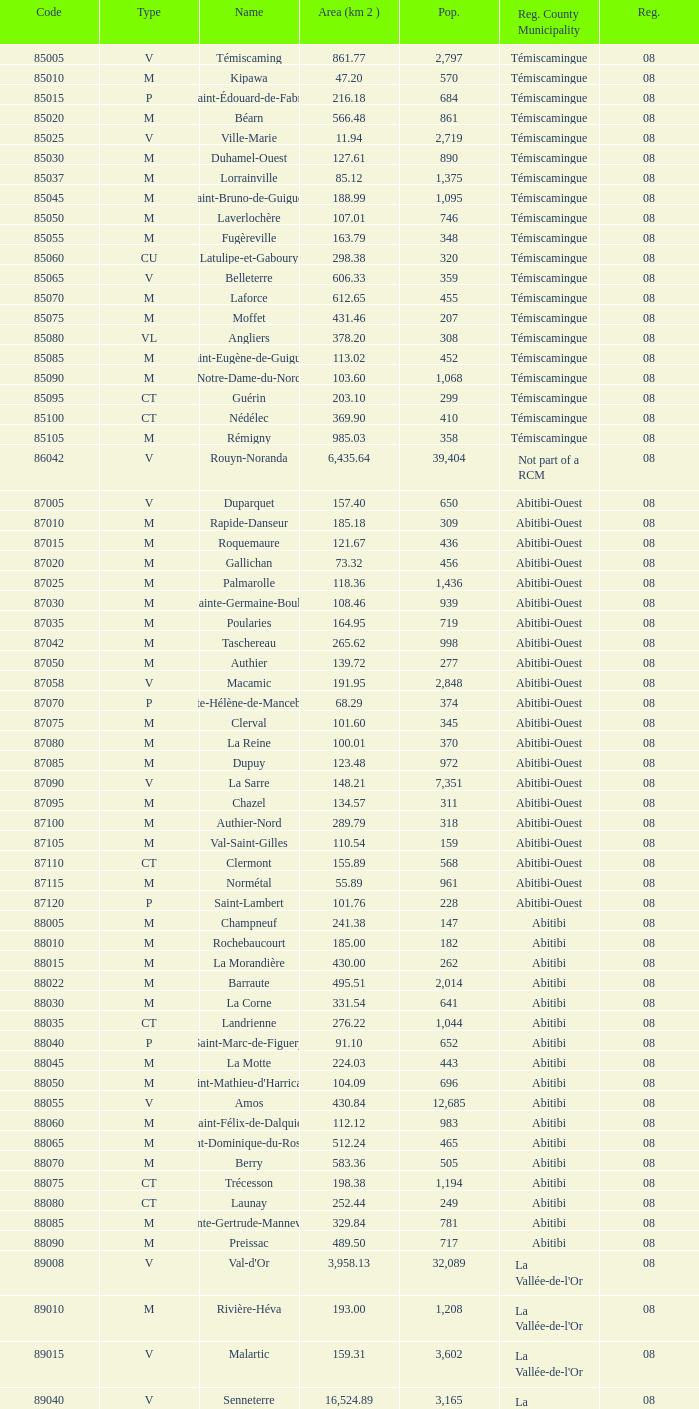What municipality has 719 people and is larger than 108.46 km2? Abitibi-Ouest. Could you help me parse every detail presented in this table? {'header': ['Code', 'Type', 'Name', 'Area (km 2 )', 'Pop.', 'Reg. County Municipality', 'Reg.'], 'rows': [['85005', 'V', 'Témiscaming', '861.77', '2,797', 'Témiscamingue', '08'], ['85010', 'M', 'Kipawa', '47.20', '570', 'Témiscamingue', '08'], ['85015', 'P', 'Saint-Édouard-de-Fabre', '216.18', '684', 'Témiscamingue', '08'], ['85020', 'M', 'Béarn', '566.48', '861', 'Témiscamingue', '08'], ['85025', 'V', 'Ville-Marie', '11.94', '2,719', 'Témiscamingue', '08'], ['85030', 'M', 'Duhamel-Ouest', '127.61', '890', 'Témiscamingue', '08'], ['85037', 'M', 'Lorrainville', '85.12', '1,375', 'Témiscamingue', '08'], ['85045', 'M', 'Saint-Bruno-de-Guigues', '188.99', '1,095', 'Témiscamingue', '08'], ['85050', 'M', 'Laverlochère', '107.01', '746', 'Témiscamingue', '08'], ['85055', 'M', 'Fugèreville', '163.79', '348', 'Témiscamingue', '08'], ['85060', 'CU', 'Latulipe-et-Gaboury', '298.38', '320', 'Témiscamingue', '08'], ['85065', 'V', 'Belleterre', '606.33', '359', 'Témiscamingue', '08'], ['85070', 'M', 'Laforce', '612.65', '455', 'Témiscamingue', '08'], ['85075', 'M', 'Moffet', '431.46', '207', 'Témiscamingue', '08'], ['85080', 'VL', 'Angliers', '378.20', '308', 'Témiscamingue', '08'], ['85085', 'M', 'Saint-Eugène-de-Guigues', '113.02', '452', 'Témiscamingue', '08'], ['85090', 'M', 'Notre-Dame-du-Nord', '103.60', '1,068', 'Témiscamingue', '08'], ['85095', 'CT', 'Guérin', '203.10', '299', 'Témiscamingue', '08'], ['85100', 'CT', 'Nédélec', '369.90', '410', 'Témiscamingue', '08'], ['85105', 'M', 'Rémigny', '985.03', '358', 'Témiscamingue', '08'], ['86042', 'V', 'Rouyn-Noranda', '6,435.64', '39,404', 'Not part of a RCM', '08'], ['87005', 'V', 'Duparquet', '157.40', '650', 'Abitibi-Ouest', '08'], ['87010', 'M', 'Rapide-Danseur', '185.18', '309', 'Abitibi-Ouest', '08'], ['87015', 'M', 'Roquemaure', '121.67', '436', 'Abitibi-Ouest', '08'], ['87020', 'M', 'Gallichan', '73.32', '456', 'Abitibi-Ouest', '08'], ['87025', 'M', 'Palmarolle', '118.36', '1,436', 'Abitibi-Ouest', '08'], ['87030', 'M', 'Sainte-Germaine-Boulé', '108.46', '939', 'Abitibi-Ouest', '08'], ['87035', 'M', 'Poularies', '164.95', '719', 'Abitibi-Ouest', '08'], ['87042', 'M', 'Taschereau', '265.62', '998', 'Abitibi-Ouest', '08'], ['87050', 'M', 'Authier', '139.72', '277', 'Abitibi-Ouest', '08'], ['87058', 'V', 'Macamic', '191.95', '2,848', 'Abitibi-Ouest', '08'], ['87070', 'P', 'Sainte-Hélène-de-Mancebourg', '68.29', '374', 'Abitibi-Ouest', '08'], ['87075', 'M', 'Clerval', '101.60', '345', 'Abitibi-Ouest', '08'], ['87080', 'M', 'La Reine', '100.01', '370', 'Abitibi-Ouest', '08'], ['87085', 'M', 'Dupuy', '123.48', '972', 'Abitibi-Ouest', '08'], ['87090', 'V', 'La Sarre', '148.21', '7,351', 'Abitibi-Ouest', '08'], ['87095', 'M', 'Chazel', '134.57', '311', 'Abitibi-Ouest', '08'], ['87100', 'M', 'Authier-Nord', '289.79', '318', 'Abitibi-Ouest', '08'], ['87105', 'M', 'Val-Saint-Gilles', '110.54', '159', 'Abitibi-Ouest', '08'], ['87110', 'CT', 'Clermont', '155.89', '568', 'Abitibi-Ouest', '08'], ['87115', 'M', 'Normétal', '55.89', '961', 'Abitibi-Ouest', '08'], ['87120', 'P', 'Saint-Lambert', '101.76', '228', 'Abitibi-Ouest', '08'], ['88005', 'M', 'Champneuf', '241.38', '147', 'Abitibi', '08'], ['88010', 'M', 'Rochebaucourt', '185.00', '182', 'Abitibi', '08'], ['88015', 'M', 'La Morandière', '430.00', '262', 'Abitibi', '08'], ['88022', 'M', 'Barraute', '495.51', '2,014', 'Abitibi', '08'], ['88030', 'M', 'La Corne', '331.54', '641', 'Abitibi', '08'], ['88035', 'CT', 'Landrienne', '276.22', '1,044', 'Abitibi', '08'], ['88040', 'P', 'Saint-Marc-de-Figuery', '91.10', '652', 'Abitibi', '08'], ['88045', 'M', 'La Motte', '224.03', '443', 'Abitibi', '08'], ['88050', 'M', "Saint-Mathieu-d'Harricana", '104.09', '696', 'Abitibi', '08'], ['88055', 'V', 'Amos', '430.84', '12,685', 'Abitibi', '08'], ['88060', 'M', 'Saint-Félix-de-Dalquier', '112.12', '983', 'Abitibi', '08'], ['88065', 'M', 'Saint-Dominique-du-Rosaire', '512.24', '465', 'Abitibi', '08'], ['88070', 'M', 'Berry', '583.36', '505', 'Abitibi', '08'], ['88075', 'CT', 'Trécesson', '198.38', '1,194', 'Abitibi', '08'], ['88080', 'CT', 'Launay', '252.44', '249', 'Abitibi', '08'], ['88085', 'M', 'Sainte-Gertrude-Manneville', '329.84', '781', 'Abitibi', '08'], ['88090', 'M', 'Preissac', '489.50', '717', 'Abitibi', '08'], ['89008', 'V', "Val-d'Or", '3,958.13', '32,089', "La Vallée-de-l'Or", '08'], ['89010', 'M', 'Rivière-Héva', '193.00', '1,208', "La Vallée-de-l'Or", '08'], ['89015', 'V', 'Malartic', '159.31', '3,602', "La Vallée-de-l'Or", '08'], ['89040', 'V', 'Senneterre', '16,524.89', '3,165', "La Vallée-de-l'Or", '08'], ['89045', 'P', 'Senneterre', '432.98', '1,146', "La Vallée-de-l'Or", '08'], ['89050', 'M', 'Belcourt', '411.23', '261', "La Vallée-de-l'Or", '08']]} 